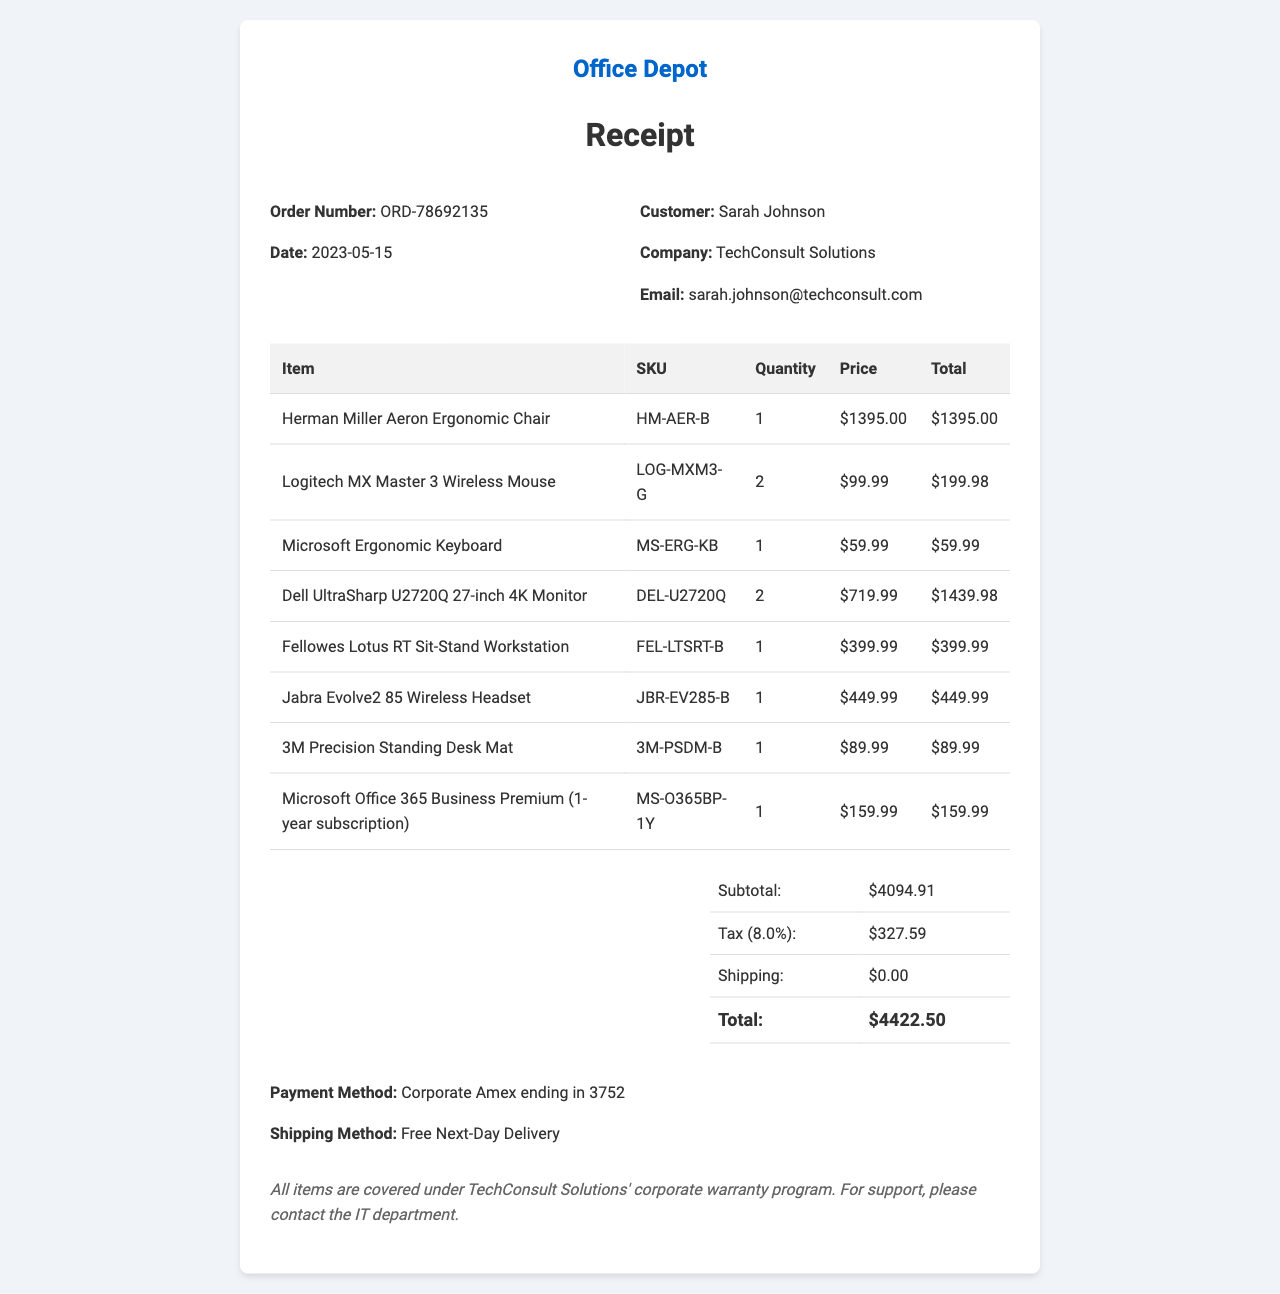What is the order number? The order number identifies this specific transaction.
Answer: ORD-78692135 Who is the customer? The customer is the person who made the purchase.
Answer: Sarah Johnson What is the date of the purchase? The date indicates when the transaction was completed.
Answer: 2023-05-15 How many Logitech MX Master 3 Wireless Mice were purchased? The quantity shows how many of this item were bought.
Answer: 2 What is the subtotal amount before tax? The subtotal is the total cost of all items before any taxes are added.
Answer: $4094.91 What is the tax amount applied to this order? The tax amount represents the sales tax charged for the transaction.
Answer: $327.59 What payment method was used for this order? This question asks for the type of payment method utilized by the customer.
Answer: Corporate Amex ending in 3752 Which shipping method was selected? The shipping method specifies how the purchased items will be delivered.
Answer: Free Next-Day Delivery What is the total amount paid for the order? The total is the complete cost including items, tax, and shipping fees.
Answer: $4422.50 